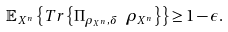Convert formula to latex. <formula><loc_0><loc_0><loc_500><loc_500>\mathbb { E } _ { X ^ { n } } \left \{ { T r } \left \{ \Pi _ { \rho _ { X ^ { n } } , \delta } \ \rho _ { X ^ { n } } \right \} \right \} \geq 1 - \epsilon .</formula> 